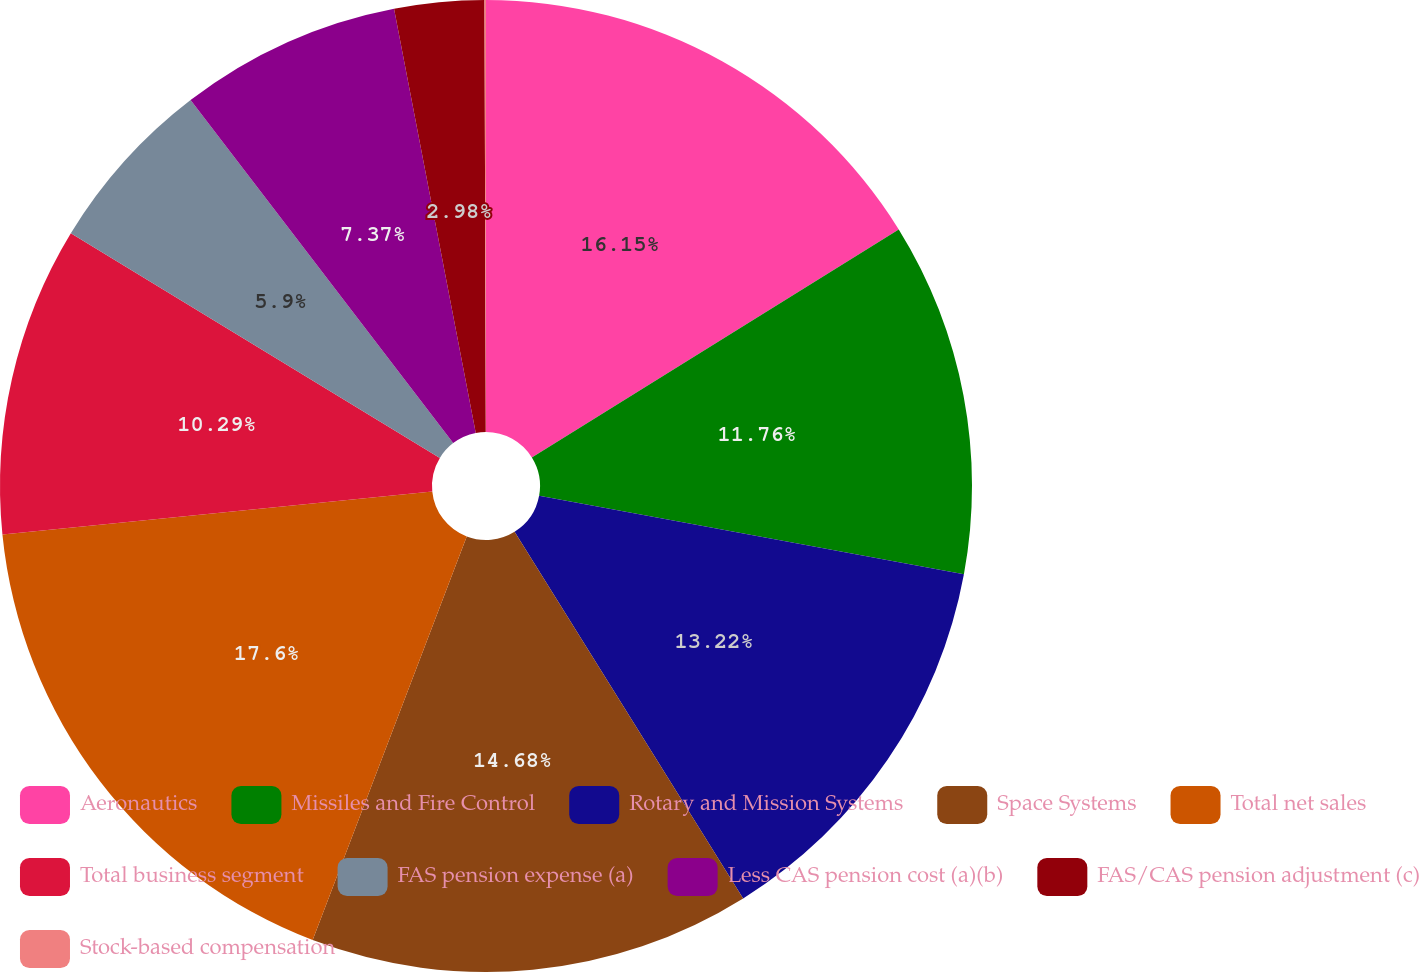Convert chart to OTSL. <chart><loc_0><loc_0><loc_500><loc_500><pie_chart><fcel>Aeronautics<fcel>Missiles and Fire Control<fcel>Rotary and Mission Systems<fcel>Space Systems<fcel>Total net sales<fcel>Total business segment<fcel>FAS pension expense (a)<fcel>Less CAS pension cost (a)(b)<fcel>FAS/CAS pension adjustment (c)<fcel>Stock-based compensation<nl><fcel>16.15%<fcel>11.76%<fcel>13.22%<fcel>14.68%<fcel>17.61%<fcel>10.29%<fcel>5.9%<fcel>7.37%<fcel>2.98%<fcel>0.05%<nl></chart> 